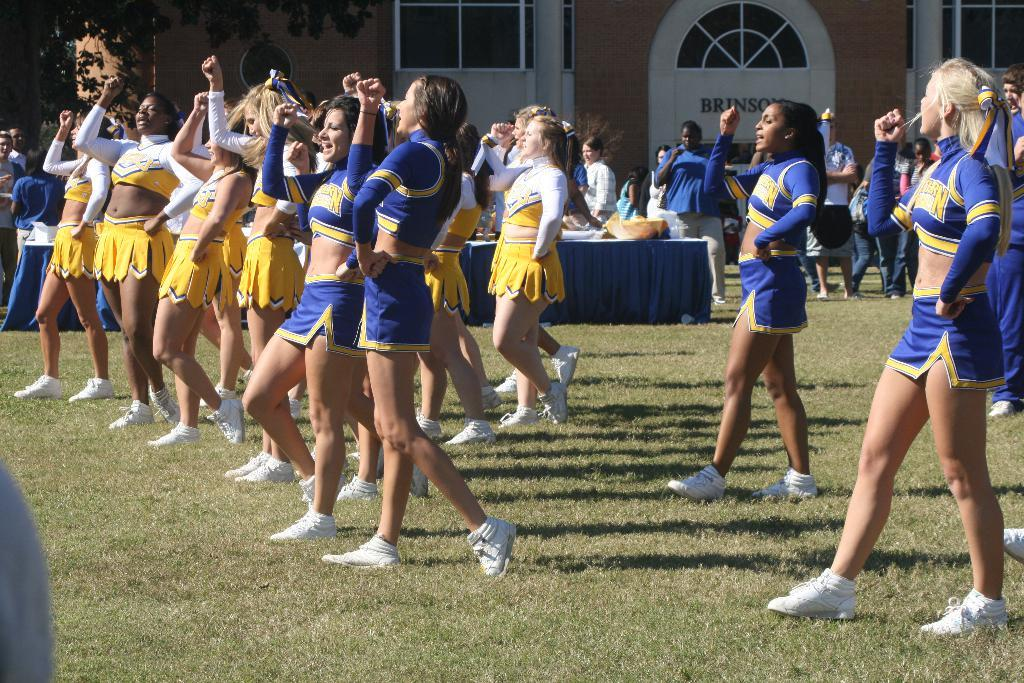<image>
Present a compact description of the photo's key features. Cheerleaders stand in front of a building called Brinson 